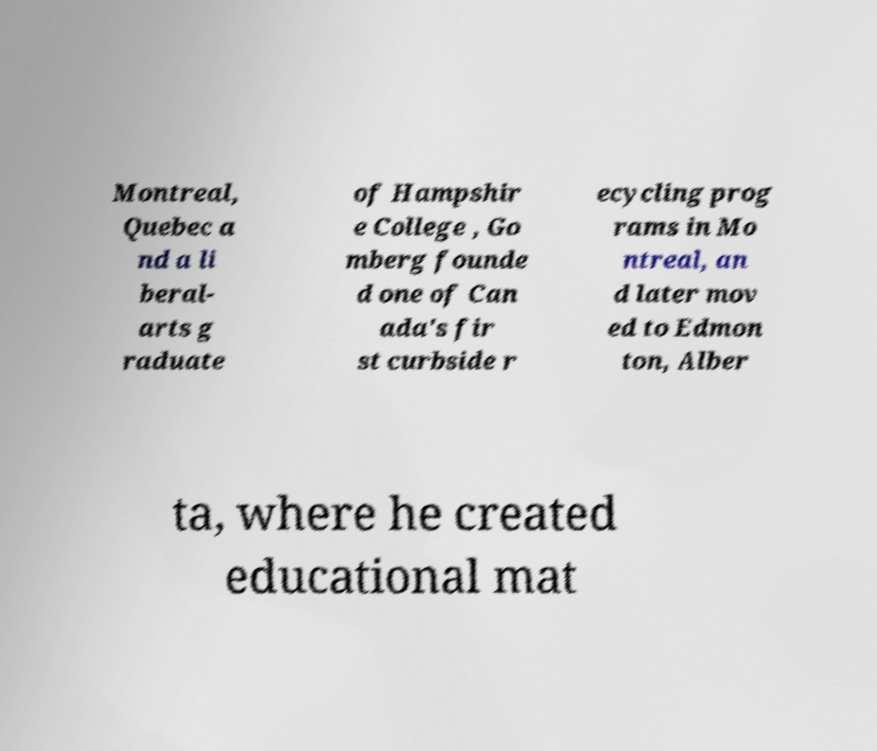For documentation purposes, I need the text within this image transcribed. Could you provide that? Montreal, Quebec a nd a li beral- arts g raduate of Hampshir e College , Go mberg founde d one of Can ada's fir st curbside r ecycling prog rams in Mo ntreal, an d later mov ed to Edmon ton, Alber ta, where he created educational mat 